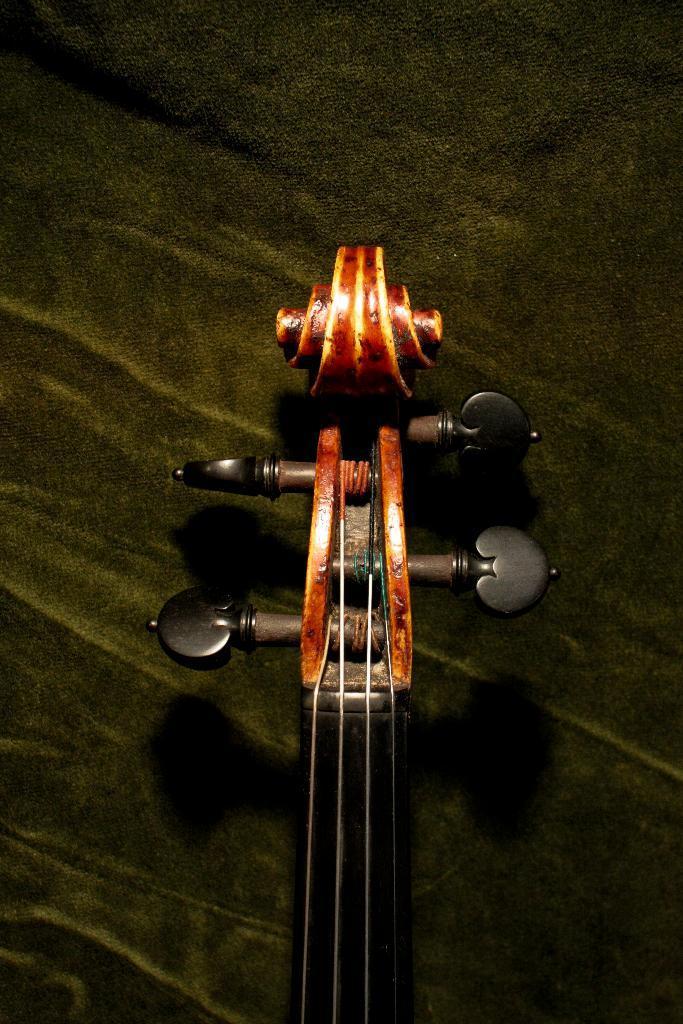Can you describe this image briefly? The guitar head is highlighted in this picture. These are tuners. 